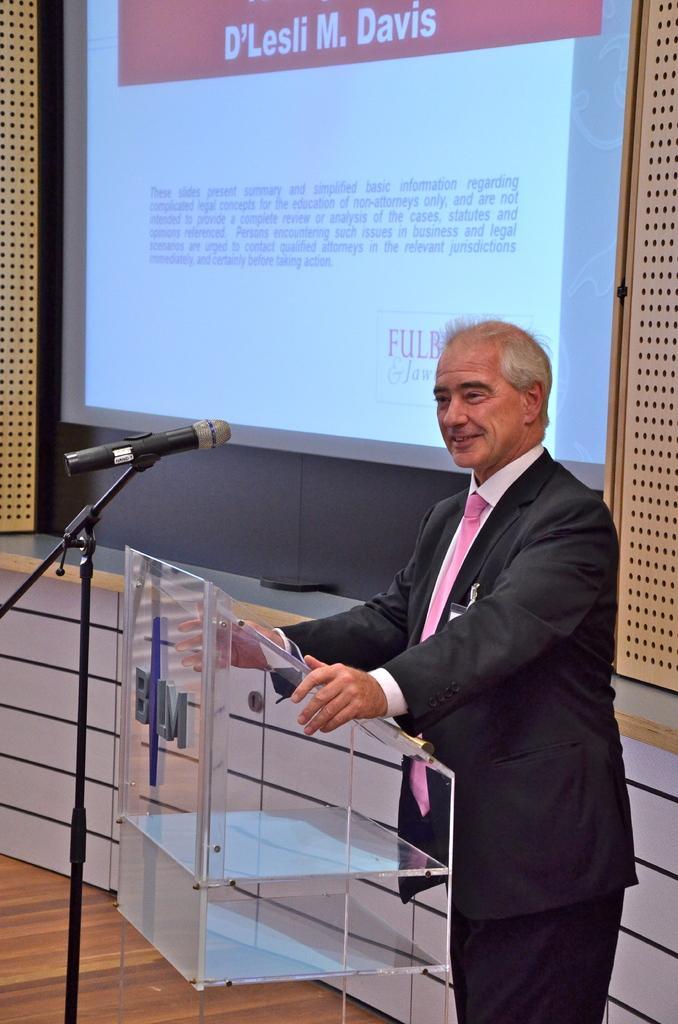Could you give a brief overview of what you see in this image? In this image we can see a person standing and in front of him there is a podium and a mic. In the background, there is a wall with a screen and on the screen we can see some text. 